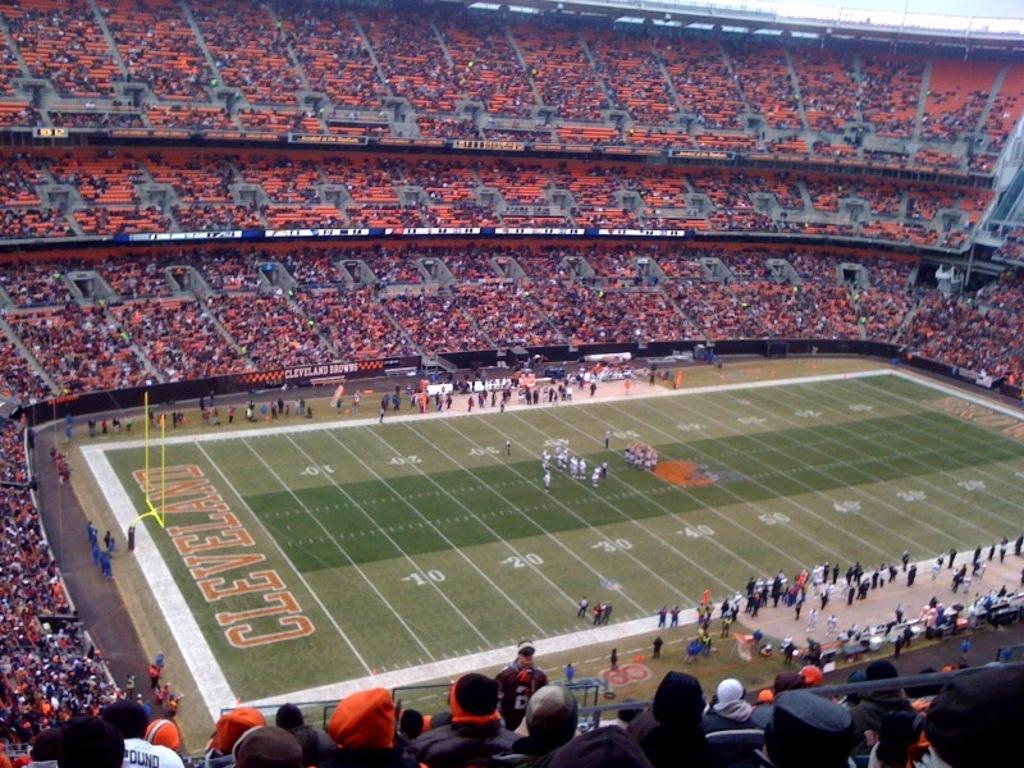<image>
Relay a brief, clear account of the picture shown. A football stadium with Cleveland painted on the turf. 